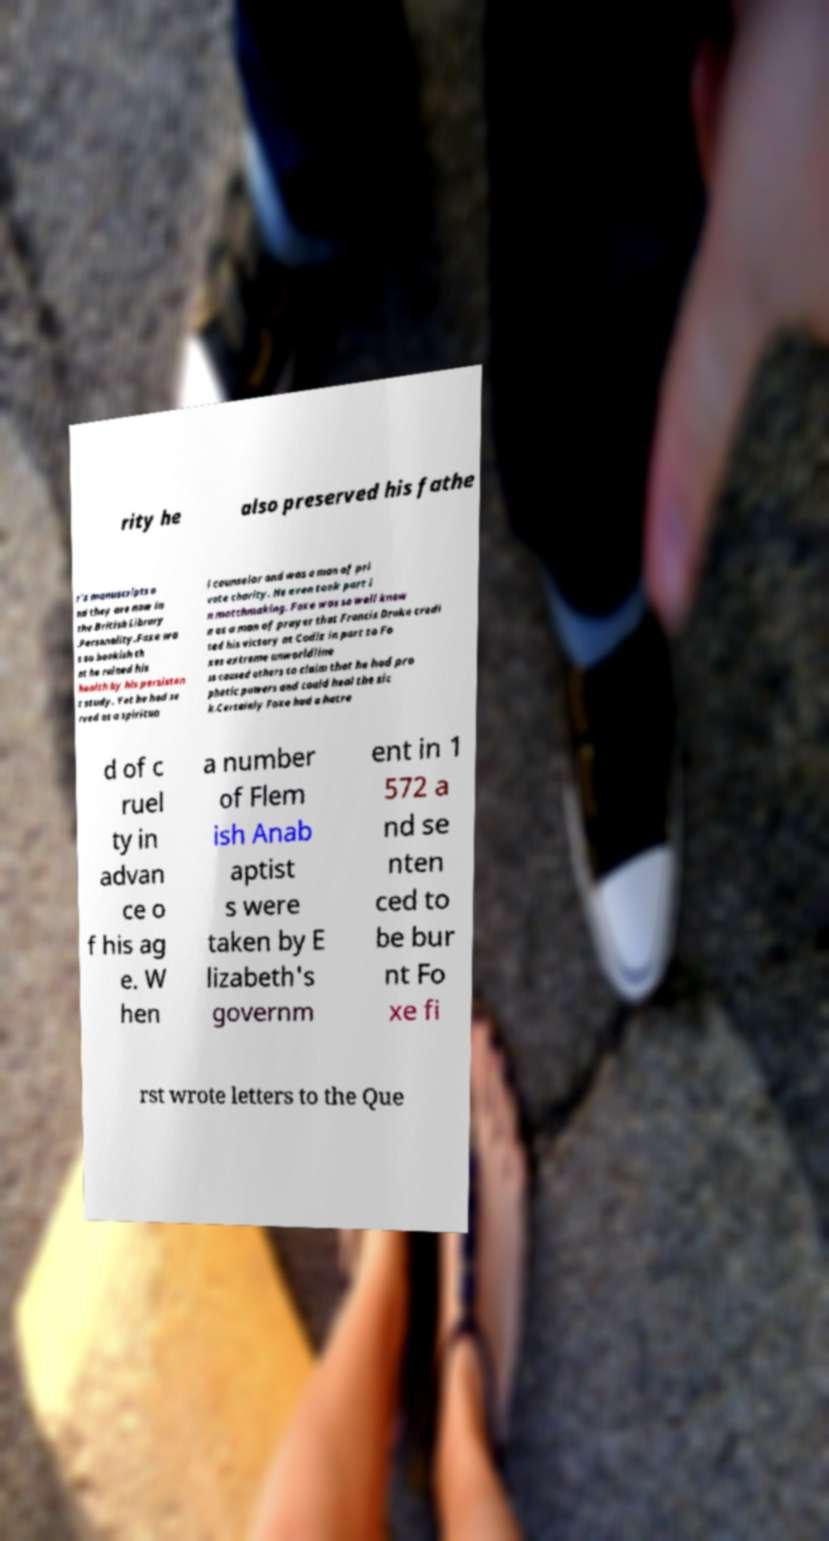What messages or text are displayed in this image? I need them in a readable, typed format. rity he also preserved his fathe r's manuscripts a nd they are now in the British Library .Personality.Foxe wa s so bookish th at he ruined his health by his persisten t study. Yet he had se rved as a spiritua l counselor and was a man of pri vate charity. He even took part i n matchmaking. Foxe was so well know n as a man of prayer that Francis Drake credi ted his victory at Cadiz in part to Fo xes extreme unworldline ss caused others to claim that he had pro phetic powers and could heal the sic k.Certainly Foxe had a hatre d of c ruel ty in advan ce o f his ag e. W hen a number of Flem ish Anab aptist s were taken by E lizabeth's governm ent in 1 572 a nd se nten ced to be bur nt Fo xe fi rst wrote letters to the Que 